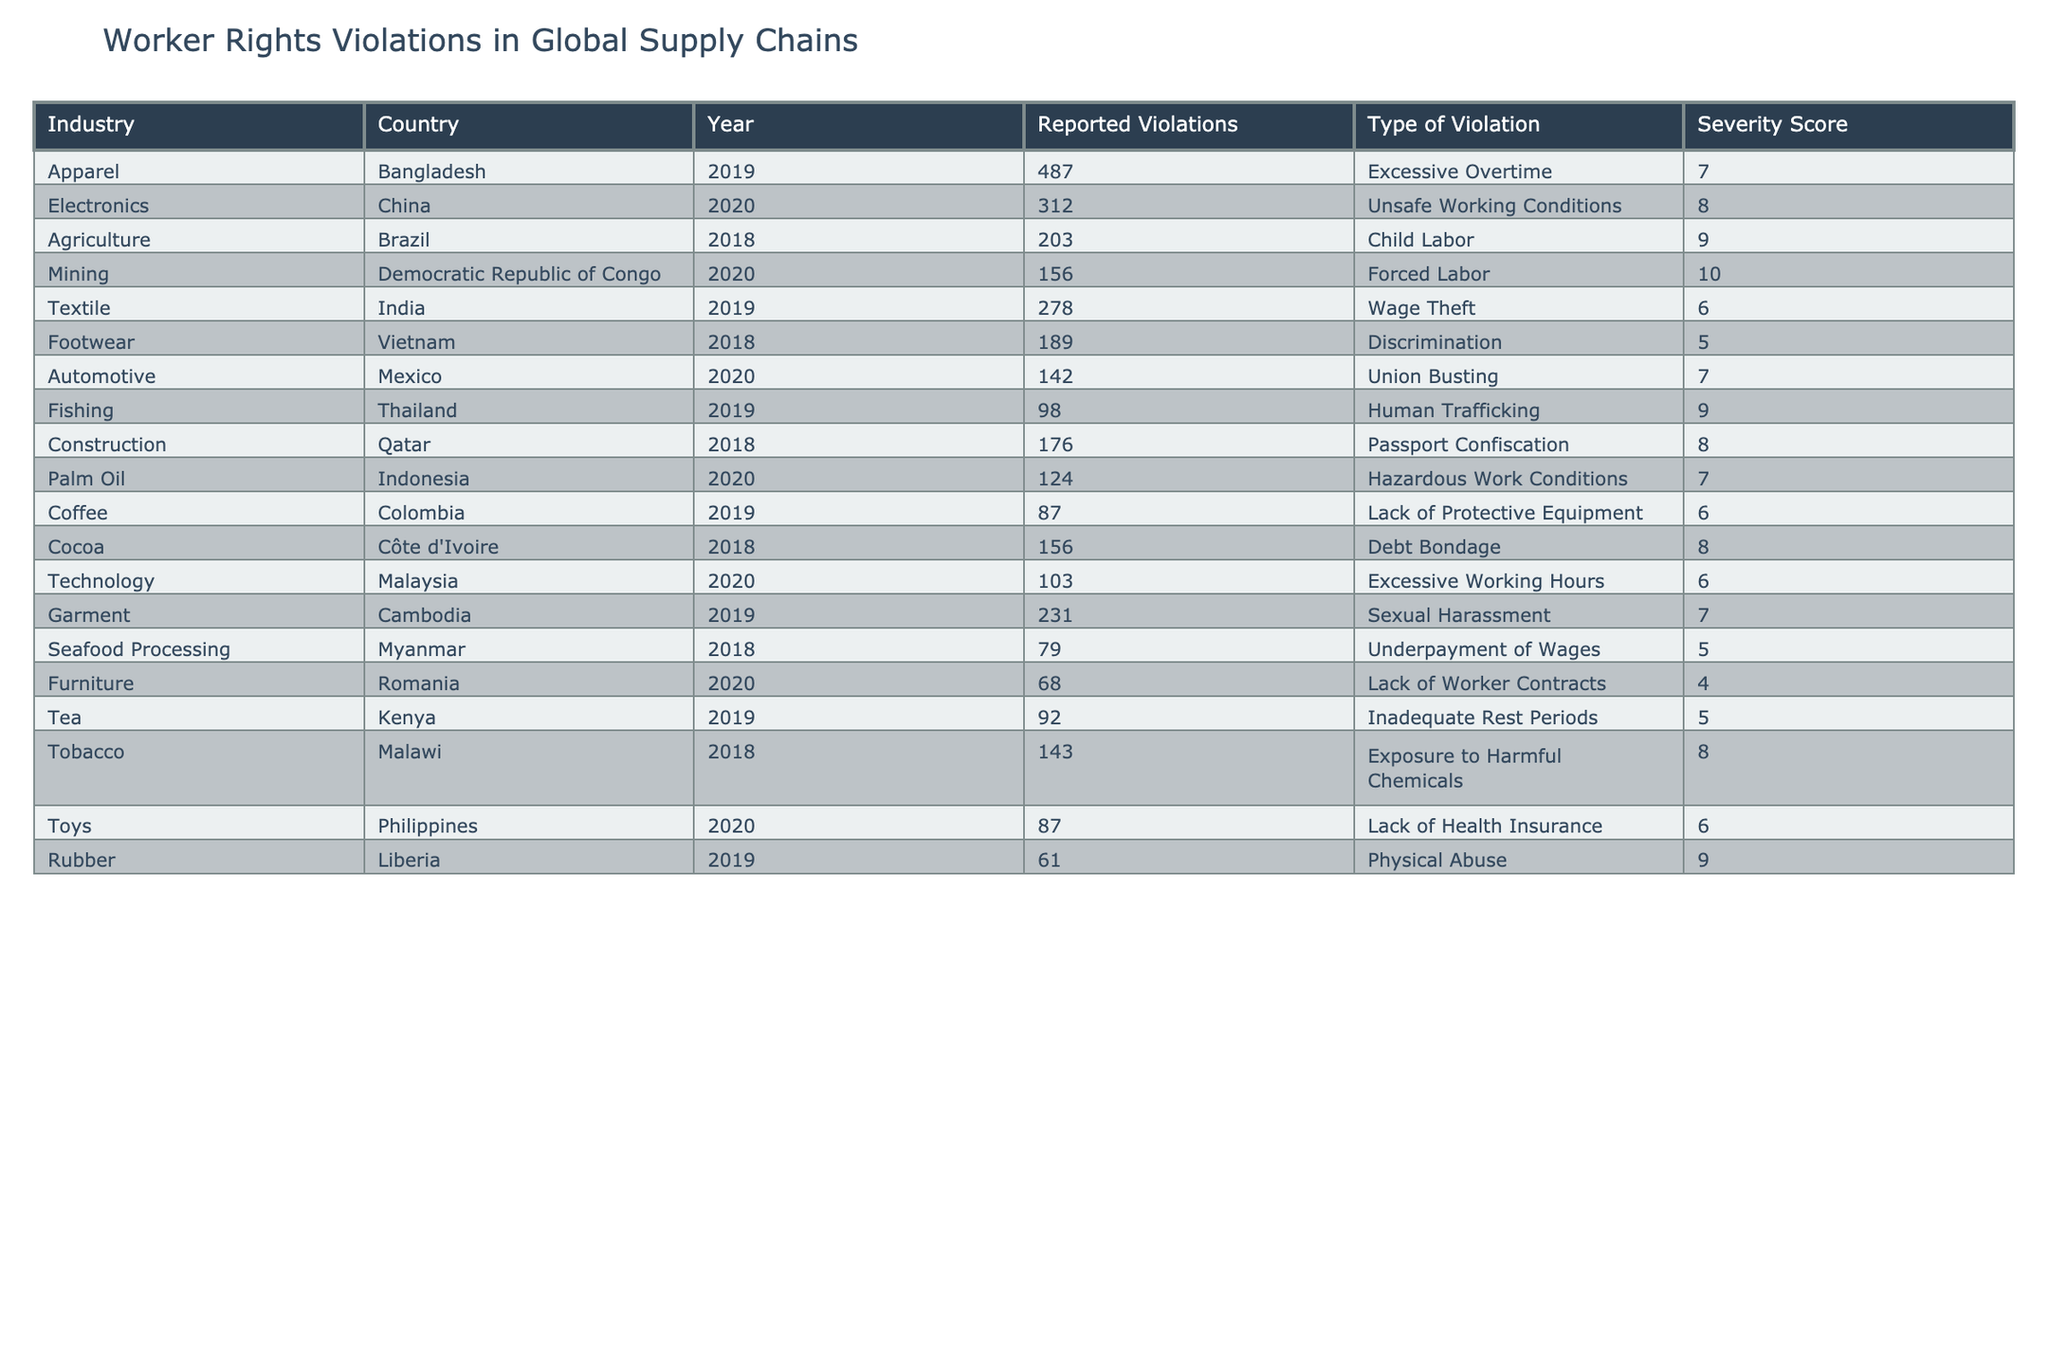What is the total number of reported violations in the Apparel industry across all years? In the table, the Apparel industry shows one entry for Bangladesh in 2019 with 487 reported violations. Since there are no other entries for other years or countries in this industry, the total remains 487.
Answer: 487 Which country reported the highest severity score for worker rights violations? The table lists several countries along with their severity scores. The Democratic Republic of Congo has the highest severity score of 10 for the type of violation 'Forced Labor,' which is greater than all other listed countries.
Answer: Democratic Republic of Congo How many total reported violations were recorded in the Electronics sector? The Electronics industry has one data entry for China in 2020, reporting 312 violations. Since there are no additional entries for Electronics, the total reported violations in this sector is solely that amount.
Answer: 312 Is it true that Brazil has reported more instances of child labor violations compared to any other type of violation in the table? The table shows Brazil with 203 reported violations for 'Child Labor', and we can compare this to other instances categorized under various violations. Since the next closest reported violation is in Bangladesh for 'Excessive Overtime' with 487 violations, the statement is not true.
Answer: No What is the average severity score of worker rights violations reported in the Fishing and Agricultural industries combined? The severity scores for the Fishing industry in Thailand is 9 and for the Agriculture industry in Brazil it's 9 as well. To find the average, add the two scores (9 + 9) = 18 and then divide by 2, yielding an average score of 9.
Answer: 9 What percentage of the total reported violations in the Fishing industry came from Thailand? The Fishing industry has only one entry for Thailand with 98 reported violations. To find the percentage, it’s necessary to consider if there are violations reported from other Fishing entries. However, since there are none, the counting equals 100%.
Answer: 100% Which industry has the least reported violations, and what is the count? By comparing the reported violations across all industries in the table, the Furniture industry has the least number of violations with a count of 68, which is lower than all the other reported instances.
Answer: Furniture, 68 How many different types of violations were reported across all entries in the table? The table shows a variety of violation types, totaling 12 distinct types: Excessive Overtime, Unsafe Working Conditions, Child Labor, Forced Labor, Wage Theft, Discrimination, Union Busting, Human Trafficking, Hazardous Work Conditions, Lack of Protective Equipment, Debt Bondage, and Sexual Harassment.
Answer: 12 What is the difference in reported violations between the highest and lowest reporting countries in the Mining and Agriculture industries? In the Mining industry, the highest reported violations are the Democratic Republic of Congo with 156, while in Agriculture, Brazil has 203. To find the difference, subtract the highest from the lowest: 203 - 156 = 47.
Answer: 47 In which year was the least number of reported violations noted, and what was the number? By comparing the total reported violations from all entries in the table, the year with the fewest violations comes from the Furniture industry (2020), with only 68 violations recorded.
Answer: 2020, 68 